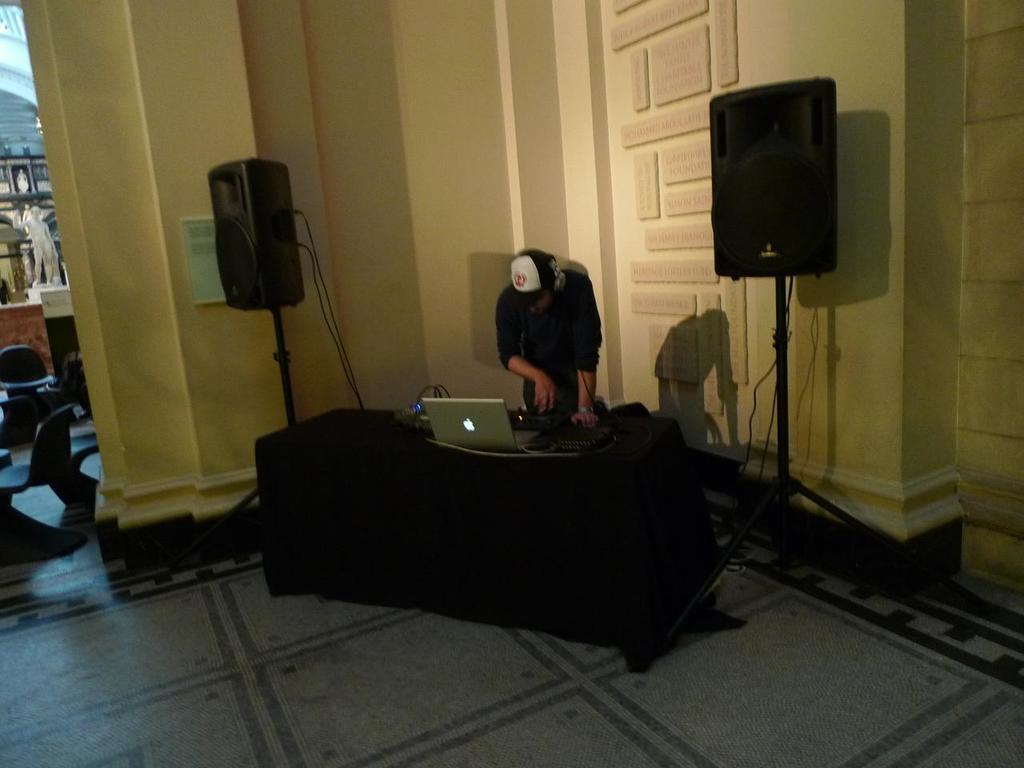How would you summarize this image in a sentence or two? Here in this picture we can see a man wearing a black t-shirt. He is wearing a cap and he is having a headphones in his ears, he is looking to the keyboard. In front of him there is a table and a black color cloth on it. On that table we can see a laptop. The either sides of the table there is a speaker. Behind him there is a wall. And right corner there is speaker. Behind that speaker there is pillar. And to the left most corner we can see some chairs which are in black color. And we can also see a statue. 